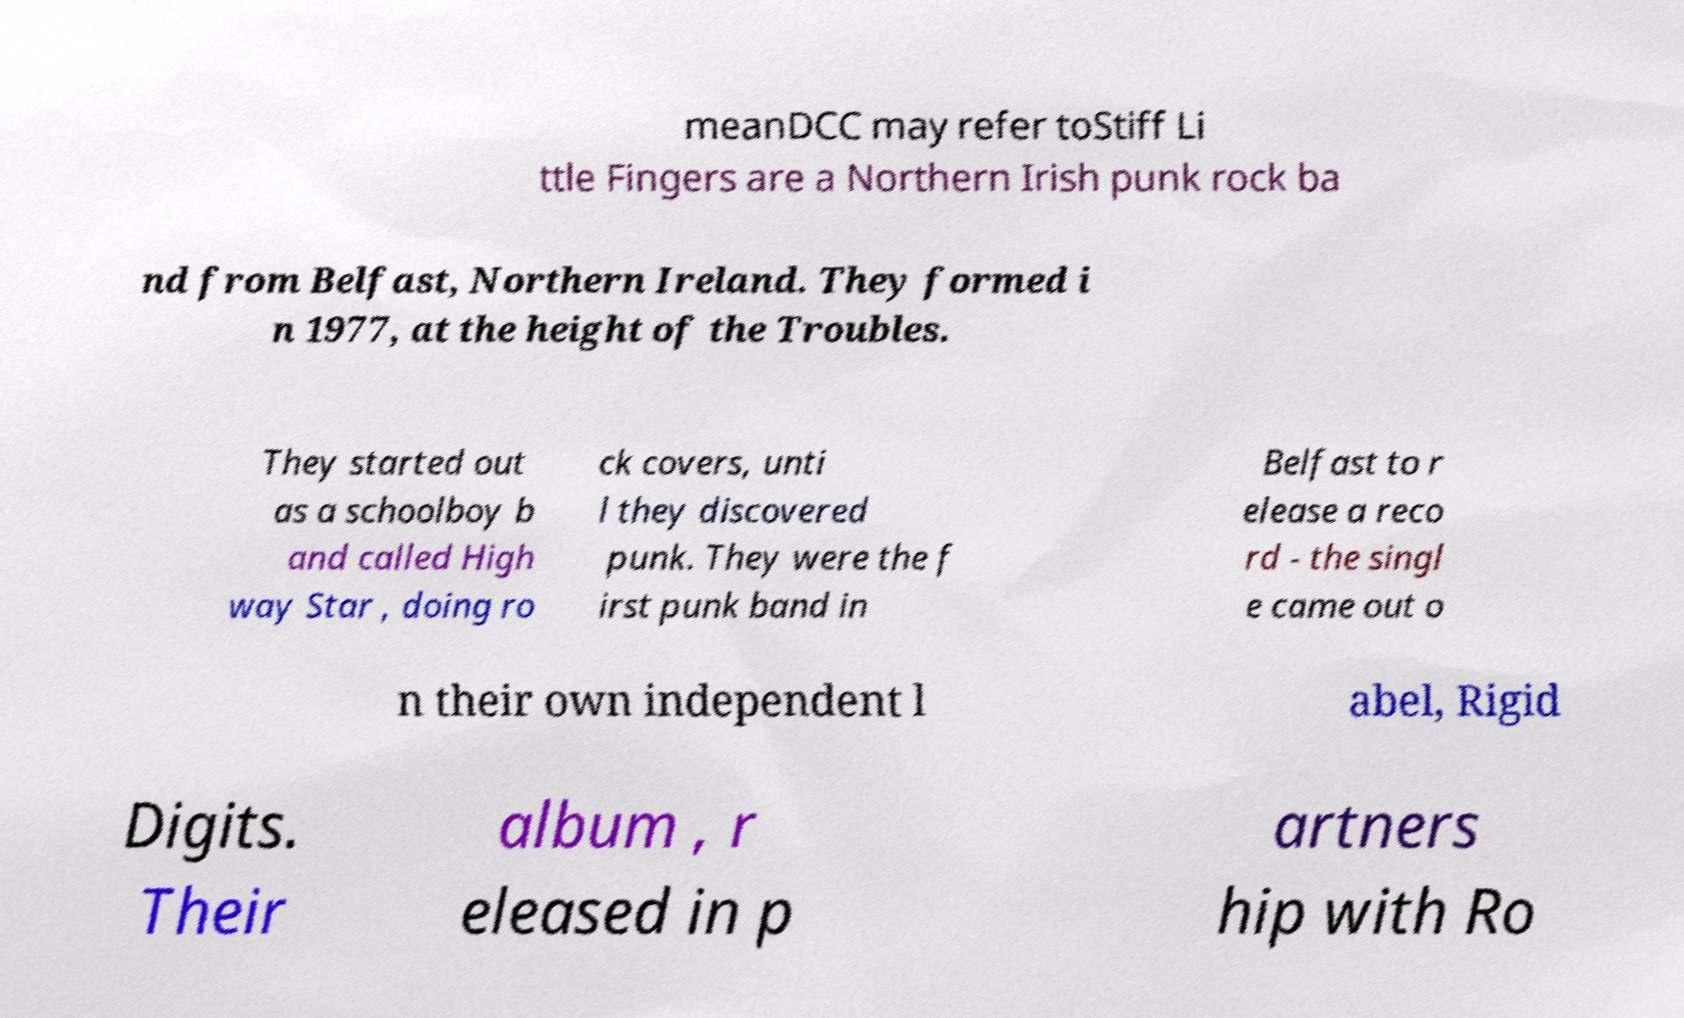What messages or text are displayed in this image? I need them in a readable, typed format. meanDCC may refer toStiff Li ttle Fingers are a Northern Irish punk rock ba nd from Belfast, Northern Ireland. They formed i n 1977, at the height of the Troubles. They started out as a schoolboy b and called High way Star , doing ro ck covers, unti l they discovered punk. They were the f irst punk band in Belfast to r elease a reco rd - the singl e came out o n their own independent l abel, Rigid Digits. Their album , r eleased in p artners hip with Ro 